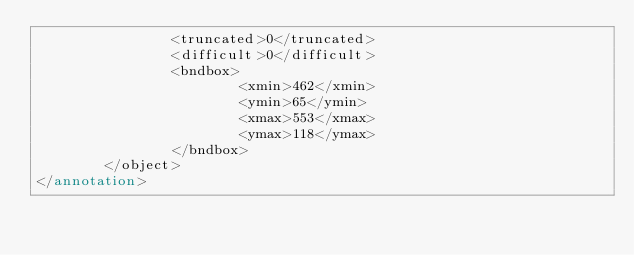<code> <loc_0><loc_0><loc_500><loc_500><_XML_>                <truncated>0</truncated>
                <difficult>0</difficult>
                <bndbox>
                        <xmin>462</xmin>
                        <ymin>65</ymin>
                        <xmax>553</xmax>
                        <ymax>118</ymax>
                </bndbox>
        </object>
</annotation>
</code> 